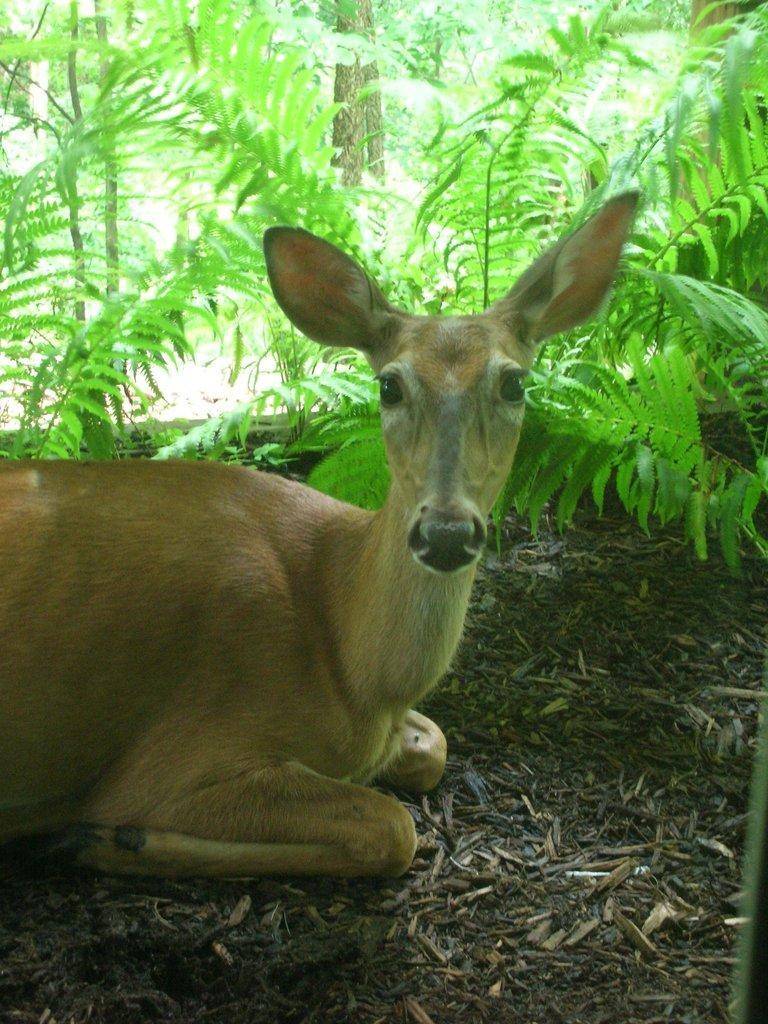Please provide a concise description of this image. In the center of the image we can see one deer,which is in brown color. In the background we can see plants etc. 